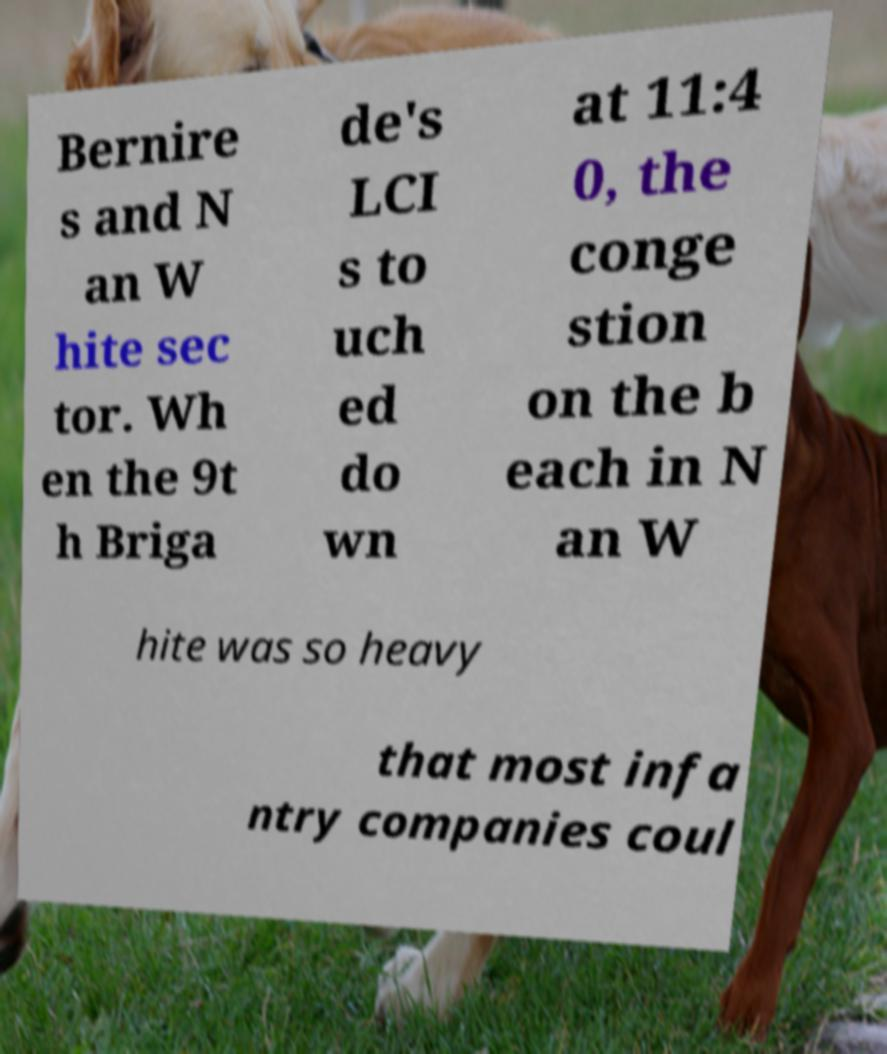Can you read and provide the text displayed in the image?This photo seems to have some interesting text. Can you extract and type it out for me? Bernire s and N an W hite sec tor. Wh en the 9t h Briga de's LCI s to uch ed do wn at 11:4 0, the conge stion on the b each in N an W hite was so heavy that most infa ntry companies coul 